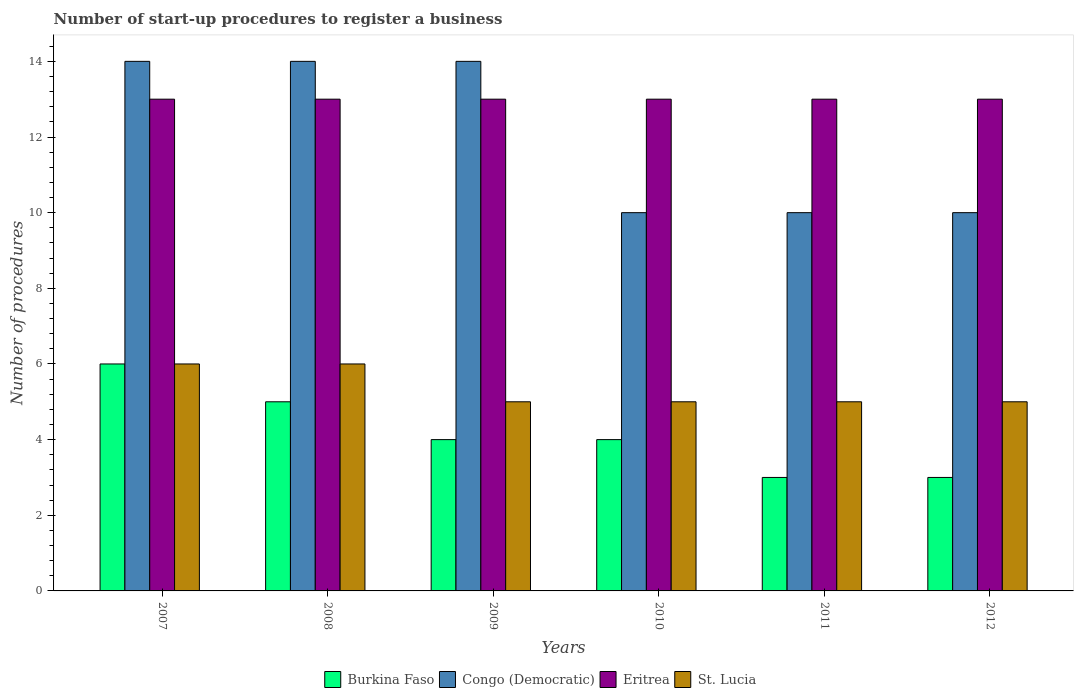How many different coloured bars are there?
Your answer should be compact. 4. How many groups of bars are there?
Your response must be concise. 6. Are the number of bars on each tick of the X-axis equal?
Your answer should be very brief. Yes. How many bars are there on the 1st tick from the left?
Keep it short and to the point. 4. In how many cases, is the number of bars for a given year not equal to the number of legend labels?
Your answer should be very brief. 0. What is the number of procedures required to register a business in Burkina Faso in 2008?
Your answer should be very brief. 5. Across all years, what is the minimum number of procedures required to register a business in Congo (Democratic)?
Ensure brevity in your answer.  10. What is the total number of procedures required to register a business in Burkina Faso in the graph?
Provide a short and direct response. 25. What is the difference between the number of procedures required to register a business in Burkina Faso in 2007 and that in 2011?
Provide a short and direct response. 3. What is the difference between the number of procedures required to register a business in Eritrea in 2007 and the number of procedures required to register a business in Congo (Democratic) in 2012?
Your response must be concise. 3. What is the average number of procedures required to register a business in Eritrea per year?
Ensure brevity in your answer.  13. In the year 2008, what is the difference between the number of procedures required to register a business in St. Lucia and number of procedures required to register a business in Congo (Democratic)?
Provide a short and direct response. -8. In how many years, is the number of procedures required to register a business in Burkina Faso greater than 3.6?
Provide a short and direct response. 4. What is the ratio of the number of procedures required to register a business in St. Lucia in 2007 to that in 2012?
Give a very brief answer. 1.2. Is the difference between the number of procedures required to register a business in St. Lucia in 2008 and 2012 greater than the difference between the number of procedures required to register a business in Congo (Democratic) in 2008 and 2012?
Make the answer very short. No. What is the difference between the highest and the lowest number of procedures required to register a business in Congo (Democratic)?
Offer a very short reply. 4. Is the sum of the number of procedures required to register a business in Burkina Faso in 2011 and 2012 greater than the maximum number of procedures required to register a business in St. Lucia across all years?
Your answer should be very brief. No. What does the 2nd bar from the left in 2007 represents?
Your response must be concise. Congo (Democratic). What does the 3rd bar from the right in 2007 represents?
Provide a succinct answer. Congo (Democratic). Is it the case that in every year, the sum of the number of procedures required to register a business in Burkina Faso and number of procedures required to register a business in St. Lucia is greater than the number of procedures required to register a business in Congo (Democratic)?
Provide a short and direct response. No. Are the values on the major ticks of Y-axis written in scientific E-notation?
Offer a terse response. No. Where does the legend appear in the graph?
Ensure brevity in your answer.  Bottom center. How many legend labels are there?
Your response must be concise. 4. What is the title of the graph?
Provide a short and direct response. Number of start-up procedures to register a business. What is the label or title of the Y-axis?
Offer a terse response. Number of procedures. What is the Number of procedures in St. Lucia in 2007?
Provide a short and direct response. 6. What is the Number of procedures of Congo (Democratic) in 2008?
Keep it short and to the point. 14. What is the Number of procedures in Congo (Democratic) in 2009?
Give a very brief answer. 14. What is the Number of procedures of Eritrea in 2009?
Your answer should be compact. 13. What is the Number of procedures in St. Lucia in 2010?
Your response must be concise. 5. What is the Number of procedures in Burkina Faso in 2012?
Your response must be concise. 3. What is the Number of procedures of Congo (Democratic) in 2012?
Keep it short and to the point. 10. Across all years, what is the maximum Number of procedures in Burkina Faso?
Provide a succinct answer. 6. Across all years, what is the maximum Number of procedures in Congo (Democratic)?
Your answer should be compact. 14. Across all years, what is the maximum Number of procedures of St. Lucia?
Ensure brevity in your answer.  6. Across all years, what is the minimum Number of procedures of Congo (Democratic)?
Provide a succinct answer. 10. Across all years, what is the minimum Number of procedures of St. Lucia?
Ensure brevity in your answer.  5. What is the total Number of procedures in Burkina Faso in the graph?
Your answer should be very brief. 25. What is the total Number of procedures of Eritrea in the graph?
Give a very brief answer. 78. What is the difference between the Number of procedures of Congo (Democratic) in 2007 and that in 2008?
Offer a terse response. 0. What is the difference between the Number of procedures of Eritrea in 2007 and that in 2008?
Give a very brief answer. 0. What is the difference between the Number of procedures of Burkina Faso in 2007 and that in 2009?
Your answer should be compact. 2. What is the difference between the Number of procedures of Congo (Democratic) in 2007 and that in 2009?
Keep it short and to the point. 0. What is the difference between the Number of procedures in Eritrea in 2007 and that in 2009?
Ensure brevity in your answer.  0. What is the difference between the Number of procedures in St. Lucia in 2007 and that in 2009?
Make the answer very short. 1. What is the difference between the Number of procedures in Congo (Democratic) in 2007 and that in 2010?
Provide a short and direct response. 4. What is the difference between the Number of procedures of Eritrea in 2007 and that in 2010?
Provide a short and direct response. 0. What is the difference between the Number of procedures in Congo (Democratic) in 2007 and that in 2011?
Give a very brief answer. 4. What is the difference between the Number of procedures of Congo (Democratic) in 2007 and that in 2012?
Your answer should be very brief. 4. What is the difference between the Number of procedures in Eritrea in 2007 and that in 2012?
Offer a very short reply. 0. What is the difference between the Number of procedures in St. Lucia in 2007 and that in 2012?
Give a very brief answer. 1. What is the difference between the Number of procedures of Burkina Faso in 2008 and that in 2010?
Your answer should be very brief. 1. What is the difference between the Number of procedures in Congo (Democratic) in 2008 and that in 2010?
Keep it short and to the point. 4. What is the difference between the Number of procedures of St. Lucia in 2008 and that in 2012?
Ensure brevity in your answer.  1. What is the difference between the Number of procedures in Congo (Democratic) in 2009 and that in 2010?
Give a very brief answer. 4. What is the difference between the Number of procedures in Congo (Democratic) in 2009 and that in 2011?
Your response must be concise. 4. What is the difference between the Number of procedures of St. Lucia in 2009 and that in 2012?
Your answer should be compact. 0. What is the difference between the Number of procedures in Burkina Faso in 2010 and that in 2011?
Your answer should be compact. 1. What is the difference between the Number of procedures in Congo (Democratic) in 2010 and that in 2011?
Provide a short and direct response. 0. What is the difference between the Number of procedures of Eritrea in 2010 and that in 2011?
Keep it short and to the point. 0. What is the difference between the Number of procedures in St. Lucia in 2010 and that in 2011?
Your answer should be very brief. 0. What is the difference between the Number of procedures in Congo (Democratic) in 2010 and that in 2012?
Your answer should be compact. 0. What is the difference between the Number of procedures of St. Lucia in 2010 and that in 2012?
Offer a very short reply. 0. What is the difference between the Number of procedures in Burkina Faso in 2007 and the Number of procedures in Congo (Democratic) in 2008?
Provide a short and direct response. -8. What is the difference between the Number of procedures in Burkina Faso in 2007 and the Number of procedures in Eritrea in 2008?
Provide a succinct answer. -7. What is the difference between the Number of procedures in Burkina Faso in 2007 and the Number of procedures in St. Lucia in 2008?
Offer a terse response. 0. What is the difference between the Number of procedures in Burkina Faso in 2007 and the Number of procedures in Congo (Democratic) in 2009?
Give a very brief answer. -8. What is the difference between the Number of procedures in Burkina Faso in 2007 and the Number of procedures in Eritrea in 2009?
Offer a terse response. -7. What is the difference between the Number of procedures in Burkina Faso in 2007 and the Number of procedures in St. Lucia in 2009?
Make the answer very short. 1. What is the difference between the Number of procedures of Congo (Democratic) in 2007 and the Number of procedures of Eritrea in 2009?
Make the answer very short. 1. What is the difference between the Number of procedures of Eritrea in 2007 and the Number of procedures of St. Lucia in 2009?
Ensure brevity in your answer.  8. What is the difference between the Number of procedures in Burkina Faso in 2007 and the Number of procedures in Congo (Democratic) in 2010?
Your response must be concise. -4. What is the difference between the Number of procedures of Burkina Faso in 2007 and the Number of procedures of St. Lucia in 2010?
Keep it short and to the point. 1. What is the difference between the Number of procedures in Congo (Democratic) in 2007 and the Number of procedures in Eritrea in 2010?
Your answer should be very brief. 1. What is the difference between the Number of procedures of Eritrea in 2007 and the Number of procedures of St. Lucia in 2010?
Ensure brevity in your answer.  8. What is the difference between the Number of procedures in Burkina Faso in 2007 and the Number of procedures in Congo (Democratic) in 2011?
Offer a very short reply. -4. What is the difference between the Number of procedures in Burkina Faso in 2007 and the Number of procedures in Eritrea in 2011?
Keep it short and to the point. -7. What is the difference between the Number of procedures in Burkina Faso in 2007 and the Number of procedures in St. Lucia in 2011?
Offer a terse response. 1. What is the difference between the Number of procedures of Congo (Democratic) in 2007 and the Number of procedures of Eritrea in 2011?
Ensure brevity in your answer.  1. What is the difference between the Number of procedures of Eritrea in 2007 and the Number of procedures of St. Lucia in 2011?
Your answer should be very brief. 8. What is the difference between the Number of procedures of Burkina Faso in 2007 and the Number of procedures of Eritrea in 2012?
Your answer should be compact. -7. What is the difference between the Number of procedures in Burkina Faso in 2007 and the Number of procedures in St. Lucia in 2012?
Offer a very short reply. 1. What is the difference between the Number of procedures of Eritrea in 2007 and the Number of procedures of St. Lucia in 2012?
Provide a short and direct response. 8. What is the difference between the Number of procedures of Burkina Faso in 2008 and the Number of procedures of St. Lucia in 2009?
Ensure brevity in your answer.  0. What is the difference between the Number of procedures in Congo (Democratic) in 2008 and the Number of procedures in St. Lucia in 2009?
Ensure brevity in your answer.  9. What is the difference between the Number of procedures of Eritrea in 2008 and the Number of procedures of St. Lucia in 2009?
Provide a short and direct response. 8. What is the difference between the Number of procedures in Burkina Faso in 2008 and the Number of procedures in Congo (Democratic) in 2010?
Provide a succinct answer. -5. What is the difference between the Number of procedures of Congo (Democratic) in 2008 and the Number of procedures of Eritrea in 2010?
Make the answer very short. 1. What is the difference between the Number of procedures of Congo (Democratic) in 2008 and the Number of procedures of St. Lucia in 2010?
Provide a succinct answer. 9. What is the difference between the Number of procedures in Eritrea in 2008 and the Number of procedures in St. Lucia in 2010?
Provide a short and direct response. 8. What is the difference between the Number of procedures in Congo (Democratic) in 2008 and the Number of procedures in Eritrea in 2011?
Your answer should be compact. 1. What is the difference between the Number of procedures of Eritrea in 2008 and the Number of procedures of St. Lucia in 2011?
Keep it short and to the point. 8. What is the difference between the Number of procedures in Burkina Faso in 2008 and the Number of procedures in Congo (Democratic) in 2012?
Offer a terse response. -5. What is the difference between the Number of procedures in Burkina Faso in 2008 and the Number of procedures in Eritrea in 2012?
Offer a terse response. -8. What is the difference between the Number of procedures in Congo (Democratic) in 2008 and the Number of procedures in St. Lucia in 2012?
Keep it short and to the point. 9. What is the difference between the Number of procedures in Burkina Faso in 2009 and the Number of procedures in Congo (Democratic) in 2010?
Keep it short and to the point. -6. What is the difference between the Number of procedures of Burkina Faso in 2009 and the Number of procedures of St. Lucia in 2010?
Your answer should be very brief. -1. What is the difference between the Number of procedures in Congo (Democratic) in 2009 and the Number of procedures in Eritrea in 2010?
Your answer should be very brief. 1. What is the difference between the Number of procedures in Burkina Faso in 2009 and the Number of procedures in St. Lucia in 2011?
Ensure brevity in your answer.  -1. What is the difference between the Number of procedures in Congo (Democratic) in 2009 and the Number of procedures in St. Lucia in 2011?
Your answer should be compact. 9. What is the difference between the Number of procedures in Eritrea in 2009 and the Number of procedures in St. Lucia in 2011?
Your answer should be very brief. 8. What is the difference between the Number of procedures in Burkina Faso in 2009 and the Number of procedures in St. Lucia in 2012?
Make the answer very short. -1. What is the difference between the Number of procedures of Congo (Democratic) in 2009 and the Number of procedures of Eritrea in 2012?
Your answer should be very brief. 1. What is the difference between the Number of procedures of Congo (Democratic) in 2009 and the Number of procedures of St. Lucia in 2012?
Your response must be concise. 9. What is the difference between the Number of procedures of Burkina Faso in 2010 and the Number of procedures of Congo (Democratic) in 2011?
Your response must be concise. -6. What is the difference between the Number of procedures of Congo (Democratic) in 2010 and the Number of procedures of St. Lucia in 2011?
Your answer should be very brief. 5. What is the difference between the Number of procedures in Eritrea in 2010 and the Number of procedures in St. Lucia in 2011?
Offer a terse response. 8. What is the difference between the Number of procedures in Burkina Faso in 2010 and the Number of procedures in Congo (Democratic) in 2012?
Provide a succinct answer. -6. What is the difference between the Number of procedures in Burkina Faso in 2011 and the Number of procedures in Congo (Democratic) in 2012?
Give a very brief answer. -7. What is the difference between the Number of procedures in Burkina Faso in 2011 and the Number of procedures in Eritrea in 2012?
Provide a succinct answer. -10. What is the difference between the Number of procedures in Burkina Faso in 2011 and the Number of procedures in St. Lucia in 2012?
Make the answer very short. -2. What is the difference between the Number of procedures of Congo (Democratic) in 2011 and the Number of procedures of Eritrea in 2012?
Give a very brief answer. -3. What is the difference between the Number of procedures of Eritrea in 2011 and the Number of procedures of St. Lucia in 2012?
Ensure brevity in your answer.  8. What is the average Number of procedures of Burkina Faso per year?
Ensure brevity in your answer.  4.17. What is the average Number of procedures in Congo (Democratic) per year?
Keep it short and to the point. 12. What is the average Number of procedures in Eritrea per year?
Provide a short and direct response. 13. What is the average Number of procedures of St. Lucia per year?
Your answer should be compact. 5.33. In the year 2007, what is the difference between the Number of procedures of Burkina Faso and Number of procedures of St. Lucia?
Your answer should be very brief. 0. In the year 2007, what is the difference between the Number of procedures in Congo (Democratic) and Number of procedures in St. Lucia?
Give a very brief answer. 8. In the year 2008, what is the difference between the Number of procedures of Burkina Faso and Number of procedures of Eritrea?
Your answer should be very brief. -8. In the year 2008, what is the difference between the Number of procedures in Eritrea and Number of procedures in St. Lucia?
Provide a short and direct response. 7. In the year 2009, what is the difference between the Number of procedures in Burkina Faso and Number of procedures in Congo (Democratic)?
Give a very brief answer. -10. In the year 2009, what is the difference between the Number of procedures of Burkina Faso and Number of procedures of St. Lucia?
Your answer should be compact. -1. In the year 2010, what is the difference between the Number of procedures of Congo (Democratic) and Number of procedures of St. Lucia?
Offer a very short reply. 5. In the year 2010, what is the difference between the Number of procedures in Eritrea and Number of procedures in St. Lucia?
Provide a succinct answer. 8. In the year 2011, what is the difference between the Number of procedures in Eritrea and Number of procedures in St. Lucia?
Keep it short and to the point. 8. In the year 2012, what is the difference between the Number of procedures of Burkina Faso and Number of procedures of Congo (Democratic)?
Give a very brief answer. -7. In the year 2012, what is the difference between the Number of procedures in Burkina Faso and Number of procedures in Eritrea?
Provide a succinct answer. -10. In the year 2012, what is the difference between the Number of procedures of Burkina Faso and Number of procedures of St. Lucia?
Keep it short and to the point. -2. In the year 2012, what is the difference between the Number of procedures in Congo (Democratic) and Number of procedures in Eritrea?
Keep it short and to the point. -3. What is the ratio of the Number of procedures of Burkina Faso in 2007 to that in 2008?
Your response must be concise. 1.2. What is the ratio of the Number of procedures in Congo (Democratic) in 2007 to that in 2008?
Make the answer very short. 1. What is the ratio of the Number of procedures in Eritrea in 2007 to that in 2008?
Provide a succinct answer. 1. What is the ratio of the Number of procedures in St. Lucia in 2007 to that in 2008?
Provide a short and direct response. 1. What is the ratio of the Number of procedures in Congo (Democratic) in 2007 to that in 2009?
Your answer should be very brief. 1. What is the ratio of the Number of procedures in Eritrea in 2007 to that in 2009?
Make the answer very short. 1. What is the ratio of the Number of procedures of Burkina Faso in 2007 to that in 2010?
Offer a very short reply. 1.5. What is the ratio of the Number of procedures of Eritrea in 2007 to that in 2011?
Ensure brevity in your answer.  1. What is the ratio of the Number of procedures of Burkina Faso in 2008 to that in 2009?
Make the answer very short. 1.25. What is the ratio of the Number of procedures in Eritrea in 2008 to that in 2009?
Provide a succinct answer. 1. What is the ratio of the Number of procedures of Burkina Faso in 2008 to that in 2010?
Ensure brevity in your answer.  1.25. What is the ratio of the Number of procedures in Congo (Democratic) in 2008 to that in 2010?
Your answer should be compact. 1.4. What is the ratio of the Number of procedures in St. Lucia in 2008 to that in 2010?
Provide a succinct answer. 1.2. What is the ratio of the Number of procedures of St. Lucia in 2008 to that in 2011?
Give a very brief answer. 1.2. What is the ratio of the Number of procedures of St. Lucia in 2008 to that in 2012?
Make the answer very short. 1.2. What is the ratio of the Number of procedures of St. Lucia in 2009 to that in 2010?
Your answer should be compact. 1. What is the ratio of the Number of procedures of Burkina Faso in 2009 to that in 2011?
Offer a very short reply. 1.33. What is the ratio of the Number of procedures in St. Lucia in 2009 to that in 2011?
Your response must be concise. 1. What is the ratio of the Number of procedures of Congo (Democratic) in 2010 to that in 2011?
Keep it short and to the point. 1. What is the ratio of the Number of procedures in Eritrea in 2010 to that in 2011?
Offer a very short reply. 1. What is the ratio of the Number of procedures in Eritrea in 2010 to that in 2012?
Keep it short and to the point. 1. What is the ratio of the Number of procedures of Congo (Democratic) in 2011 to that in 2012?
Make the answer very short. 1. What is the ratio of the Number of procedures of St. Lucia in 2011 to that in 2012?
Keep it short and to the point. 1. What is the difference between the highest and the second highest Number of procedures of Burkina Faso?
Give a very brief answer. 1. What is the difference between the highest and the second highest Number of procedures in Eritrea?
Your answer should be compact. 0. What is the difference between the highest and the lowest Number of procedures of Burkina Faso?
Keep it short and to the point. 3. 